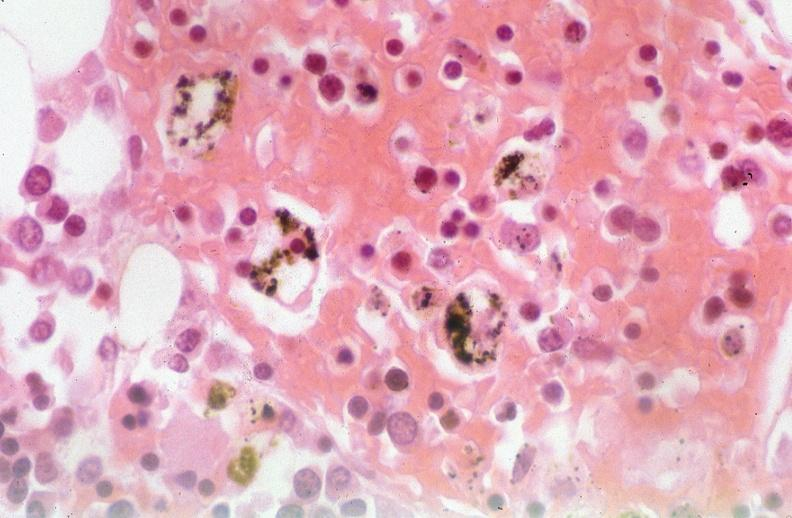what is present?
Answer the question using a single word or phrase. Respiratory 